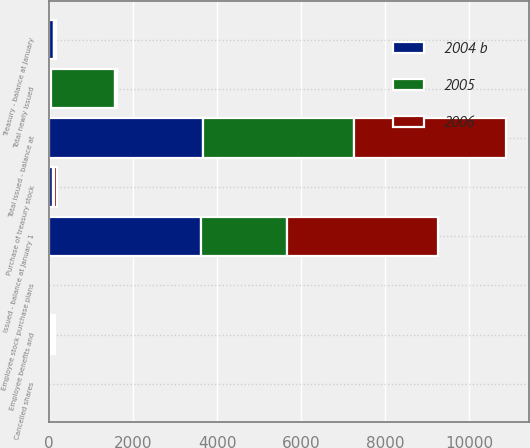Convert chart to OTSL. <chart><loc_0><loc_0><loc_500><loc_500><stacked_bar_chart><ecel><fcel>Issued - balance at January 1<fcel>Employee benefits and<fcel>Employee stock purchase plans<fcel>Total newly issued<fcel>Cancelled shares<fcel>Total issued - balance at<fcel>Treasury - balance at January<fcel>Purchase of treasury stock<nl><fcel>2004 b<fcel>3618.2<fcel>39.3<fcel>0.6<fcel>39.9<fcel>0.3<fcel>3657.8<fcel>131.5<fcel>90.7<nl><fcel>2006<fcel>3584.8<fcel>34<fcel>1.4<fcel>35.4<fcel>2<fcel>3618.2<fcel>28.6<fcel>93.5<nl><fcel>2005<fcel>2044.4<fcel>69<fcel>3.1<fcel>1541.5<fcel>1.1<fcel>3584.8<fcel>1.8<fcel>19.3<nl></chart> 